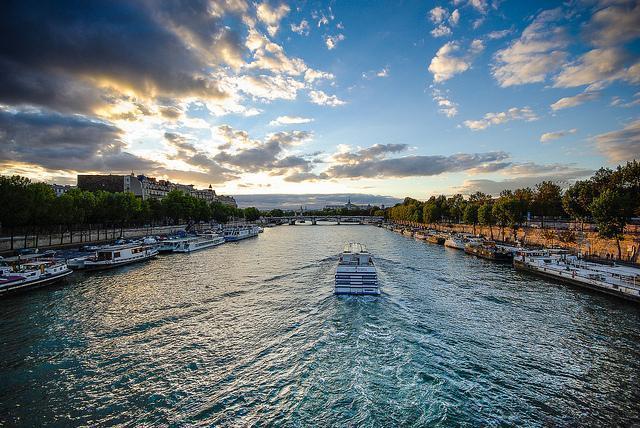How many sailboats are there?
Give a very brief answer. 0. How many boats can be seen?
Give a very brief answer. 2. 